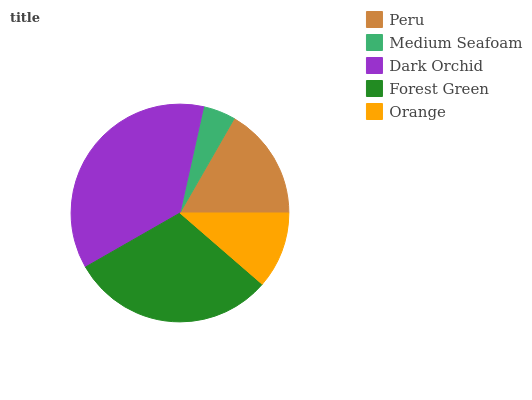Is Medium Seafoam the minimum?
Answer yes or no. Yes. Is Dark Orchid the maximum?
Answer yes or no. Yes. Is Dark Orchid the minimum?
Answer yes or no. No. Is Medium Seafoam the maximum?
Answer yes or no. No. Is Dark Orchid greater than Medium Seafoam?
Answer yes or no. Yes. Is Medium Seafoam less than Dark Orchid?
Answer yes or no. Yes. Is Medium Seafoam greater than Dark Orchid?
Answer yes or no. No. Is Dark Orchid less than Medium Seafoam?
Answer yes or no. No. Is Peru the high median?
Answer yes or no. Yes. Is Peru the low median?
Answer yes or no. Yes. Is Dark Orchid the high median?
Answer yes or no. No. Is Forest Green the low median?
Answer yes or no. No. 